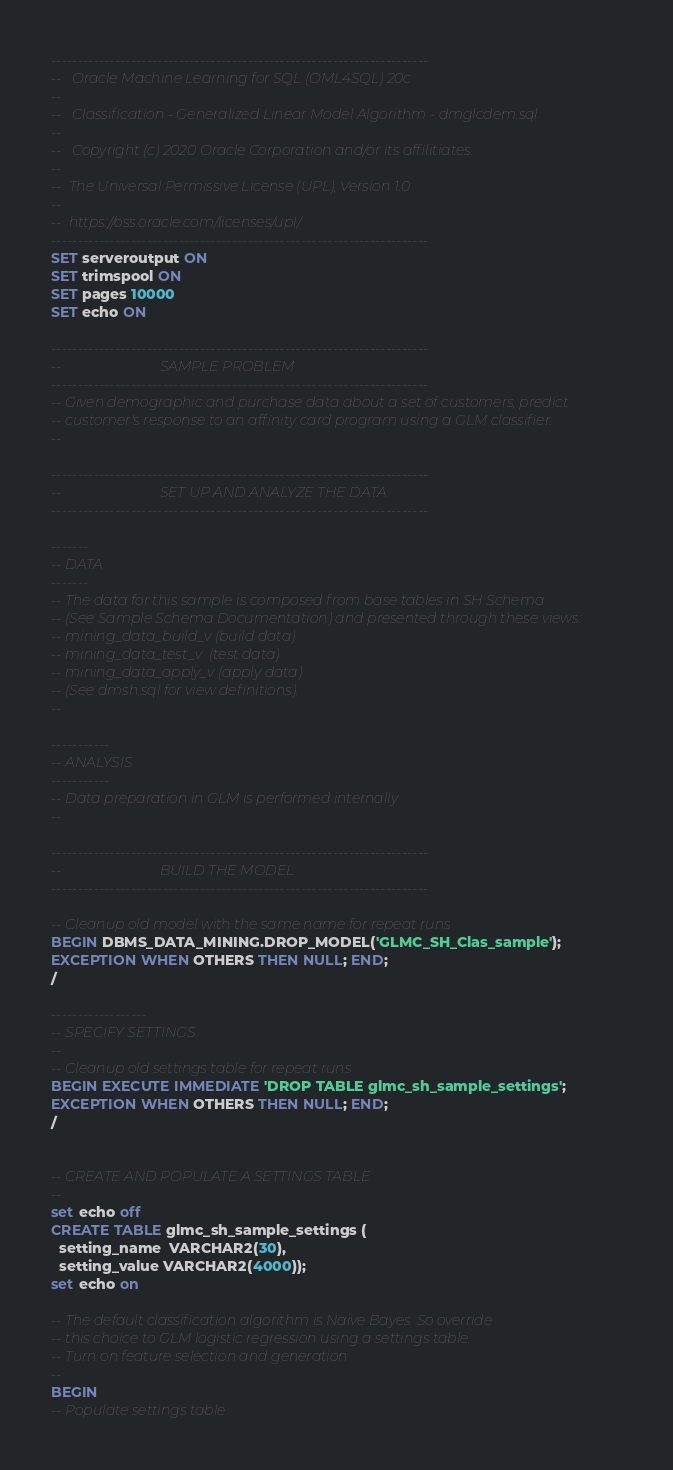<code> <loc_0><loc_0><loc_500><loc_500><_SQL_>-----------------------------------------------------------------------
--   Oracle Machine Learning for SQL (OML4SQL) 20c
-- 
--   Classification - Generalized Linear Model Algorithm - dmglcdem.sql
--   
--   Copyright (c) 2020 Oracle Corporation and/or its affilitiates.
--
--  The Universal Permissive License (UPL), Version 1.0
--
--  https://oss.oracle.com/licenses/upl/
-----------------------------------------------------------------------
SET serveroutput ON
SET trimspool ON  
SET pages 10000
SET echo ON

-----------------------------------------------------------------------
--                            SAMPLE PROBLEM
-----------------------------------------------------------------------
-- Given demographic and purchase data about a set of customers, predict
-- customer's response to an affinity card program using a GLM classifier.
--

-----------------------------------------------------------------------
--                            SET UP AND ANALYZE THE DATA
-----------------------------------------------------------------------

-------
-- DATA
-------
-- The data for this sample is composed from base tables in SH Schema
-- (See Sample Schema Documentation) and presented through these views:
-- mining_data_build_v (build data)
-- mining_data_test_v  (test data)
-- mining_data_apply_v (apply data)
-- (See dmsh.sql for view definitions).
--

-----------
-- ANALYSIS
-----------
-- Data preparation in GLM is performed internally
--

-----------------------------------------------------------------------
--                            BUILD THE MODEL
-----------------------------------------------------------------------

-- Cleanup old model with the same name for repeat runs
BEGIN DBMS_DATA_MINING.DROP_MODEL('GLMC_SH_Clas_sample');
EXCEPTION WHEN OTHERS THEN NULL; END;
/

------------------
-- SPECIFY SETTINGS
--
-- Cleanup old settings table for repeat runs
BEGIN EXECUTE IMMEDIATE 'DROP TABLE glmc_sh_sample_settings';
EXCEPTION WHEN OTHERS THEN NULL; END;
/


-- CREATE AND POPULATE A SETTINGS TABLE
--
set echo off
CREATE TABLE glmc_sh_sample_settings (
  setting_name  VARCHAR2(30),
  setting_value VARCHAR2(4000));
set echo on

-- The default classification algorithm is Naive Bayes. So override
-- this choice to GLM logistic regression using a settings table. 
-- Turn on feature selection and generation
--    
BEGIN 
-- Populate settings table</code> 